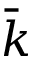<formula> <loc_0><loc_0><loc_500><loc_500>\bar { k }</formula> 